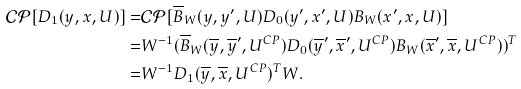<formula> <loc_0><loc_0><loc_500><loc_500>\mathcal { C P } [ D _ { 1 } ( y , x , U ) ] = & \mathcal { C P } [ \overline { B } _ { W } ( y , y ^ { \prime } , U ) D _ { 0 } ( y ^ { \prime } , x ^ { \prime } , U ) B _ { W } ( x ^ { \prime } , x , U ) ] \\ = & W ^ { - 1 } ( \overline { B } _ { W } ( \overline { y } , \overline { y } ^ { \prime } , U ^ { C P } ) D _ { 0 } ( \overline { y } ^ { \prime } , \overline { x } ^ { \prime } , U ^ { C P } ) B _ { W } ( \overline { x } ^ { \prime } , \overline { x } , U ^ { C P } ) ) ^ { T } \\ = & W ^ { - 1 } D _ { 1 } ( \overline { y } , \overline { x } , U ^ { C P } ) ^ { T } W .</formula> 